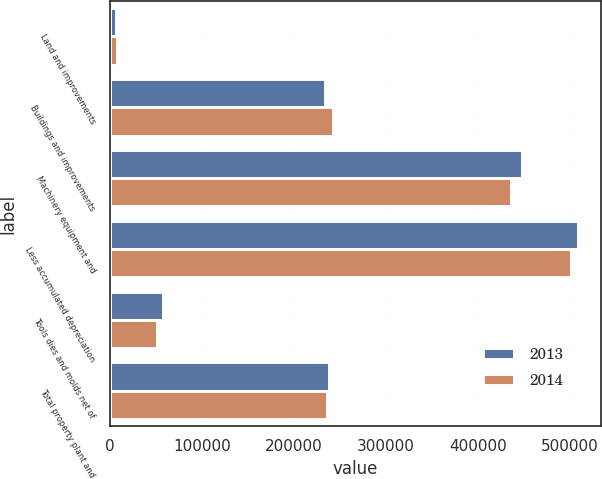<chart> <loc_0><loc_0><loc_500><loc_500><stacked_bar_chart><ecel><fcel>Land and improvements<fcel>Buildings and improvements<fcel>Machinery equipment and<fcel>Less accumulated depreciation<fcel>Tools dies and molds net of<fcel>Total property plant and<nl><fcel>2013<fcel>6784<fcel>234149<fcel>447434<fcel>508600<fcel>57722<fcel>237489<nl><fcel>2014<fcel>7870<fcel>241886<fcel>435778<fcel>500478<fcel>51207<fcel>236263<nl></chart> 